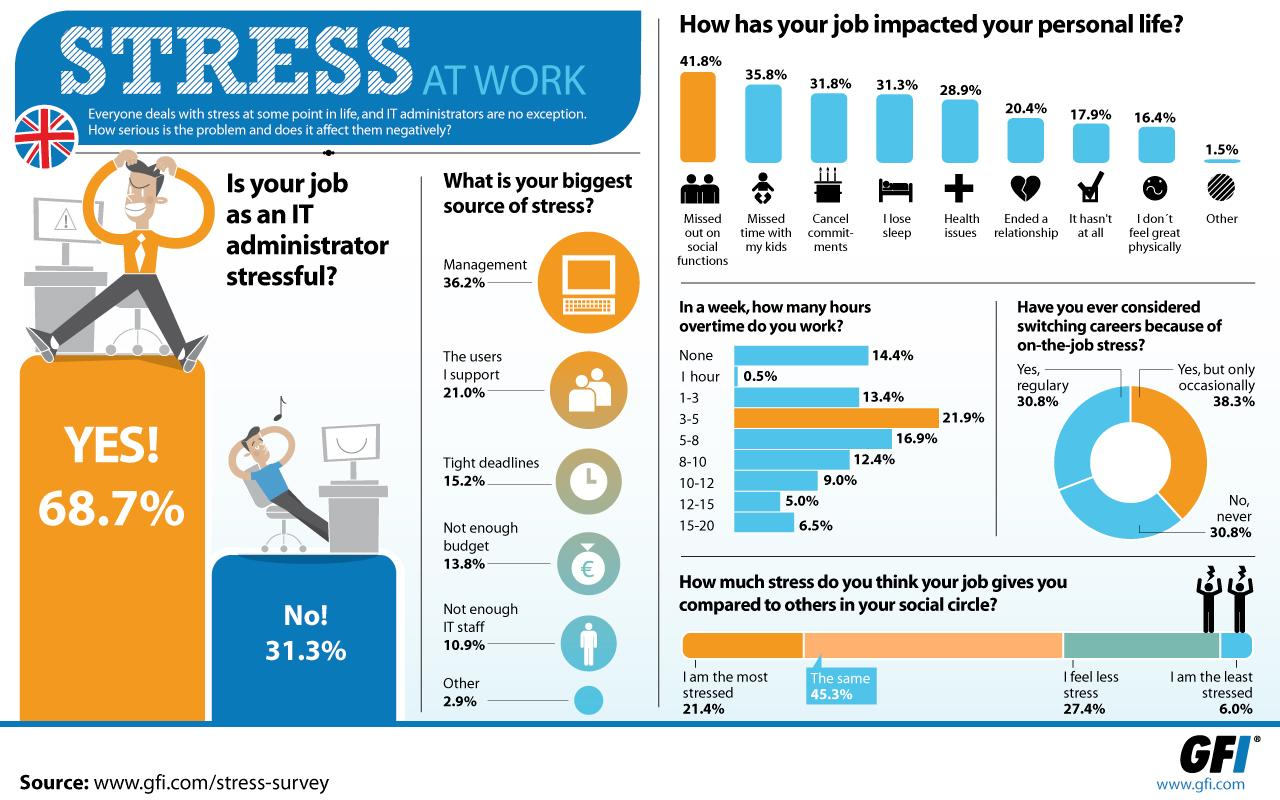Identify some key points in this picture. The UK employees work an average of 1-3 hours of overtime per week, with 13.4% of them working more than 10 hours of overtime per week. A recent study in the UK found that 20.4% of people ended a relationship due to their stressful job. In the UK, approximately 30.8% of individuals have never considered switching their jobs due to job-related stress. The majority of employees in the UK work overtime, with the amount of hours varying between 3 and 5. According to a recent survey in the UK, a significant proportion of individuals reported missing time with their children due to the stress of their job, with 35.8% of respondents citing this as a reason for their absence. 